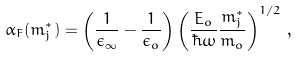Convert formula to latex. <formula><loc_0><loc_0><loc_500><loc_500>\alpha _ { F } ( m ^ { * } _ { j } ) = \left ( \frac { 1 } { \epsilon _ { \infty } } - \frac { 1 } { \epsilon _ { o } } \right ) \left ( \frac { E _ { o } } { \hbar { \omega } } \frac { m ^ { * } _ { j } } { m _ { o } } \right ) ^ { 1 / 2 } \, ,</formula> 